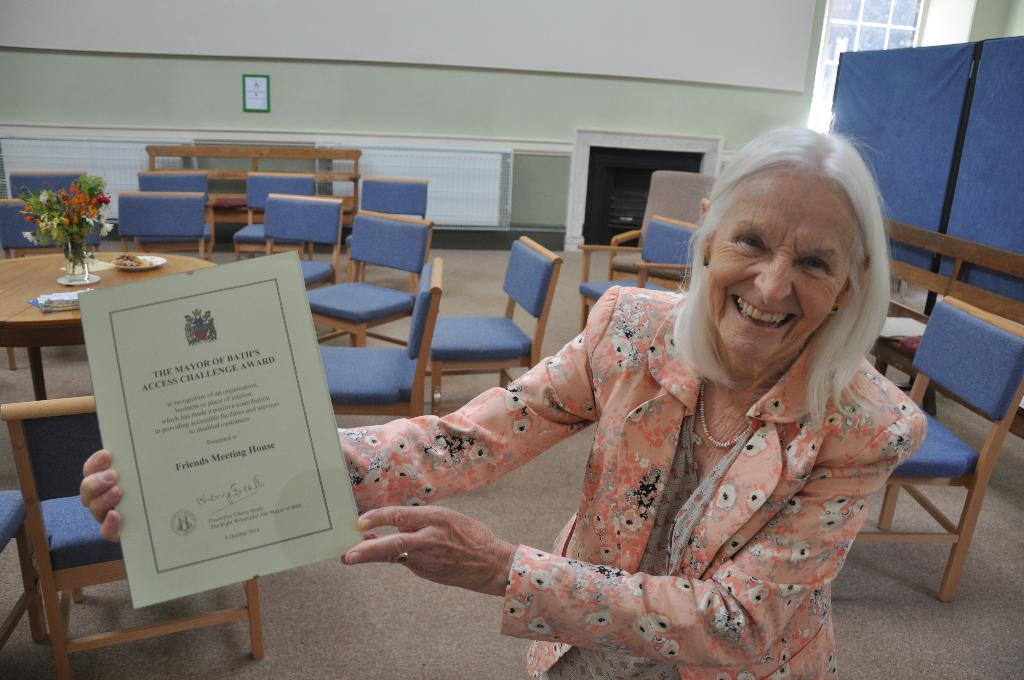Who is present in the image? There is a woman in the image. What is the woman doing in the image? The woman is standing and holding a certificate in her hands. How does the woman appear in the image? The woman has a smile on her face. What type of furniture can be seen in the image? There are chairs and tables in the image. What is hanging on the wall in the image? There is a photo frame on the wall. What type of fruit is needed to complete the woman's meal in the image? There is no indication of a meal or fruit in the image; it only shows a woman holding a certificate with a smile on her face. 